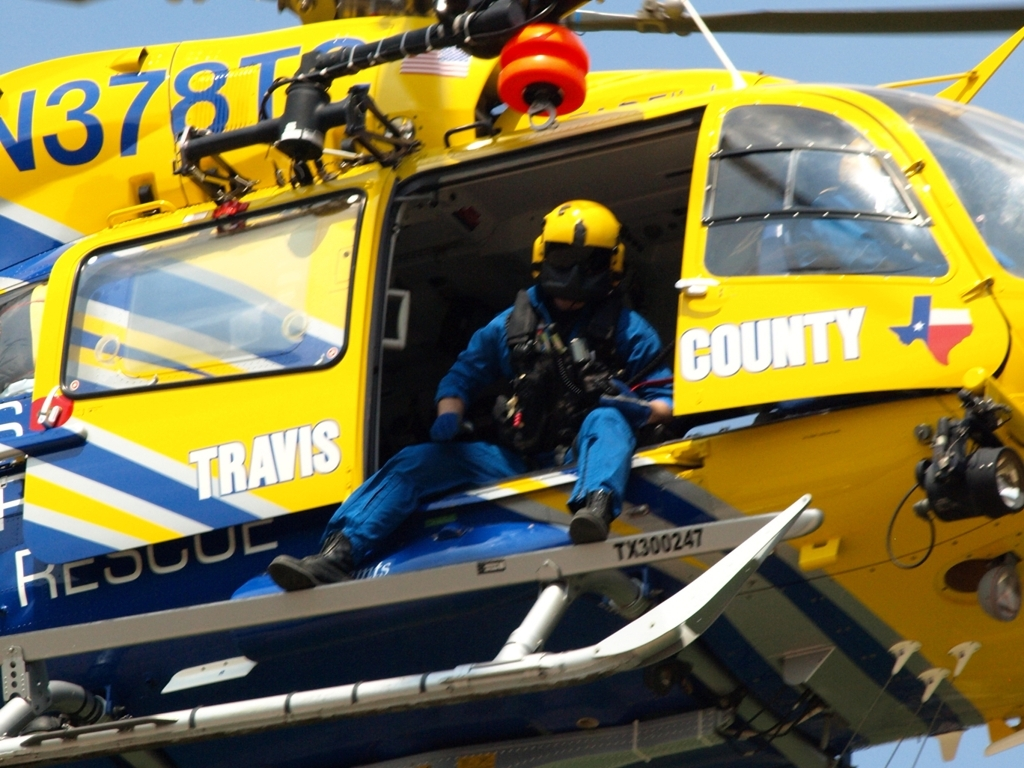What can you infer about the equipment and the preparedness of the team? Based on the image, the rescue team appears to be well-equipped for a high-risk operation. The rescue worker wears a helmet and protective flight suit and is secured with safety harnesses, suggesting a focus on personal safety. The presence of a hoist and other specialized equipment indicates a high degree of preparedness to perform aerial rescues and provide immediate assistance. 